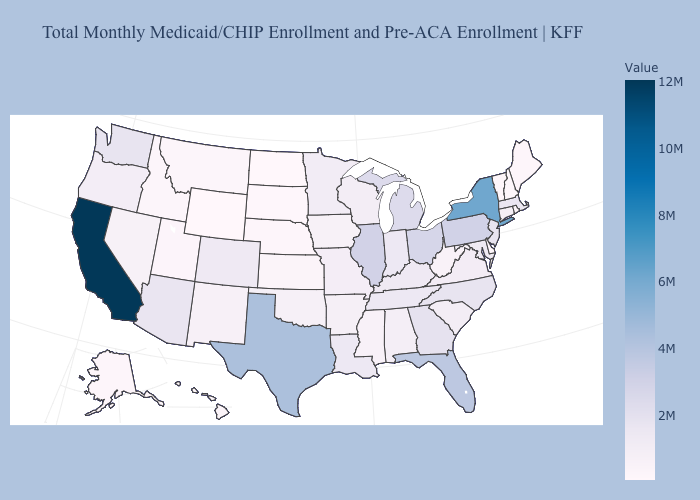Among the states that border New Mexico , does Utah have the lowest value?
Give a very brief answer. Yes. Among the states that border South Dakota , does Iowa have the highest value?
Keep it brief. No. Which states have the highest value in the USA?
Keep it brief. California. Which states have the highest value in the USA?
Give a very brief answer. California. Among the states that border New York , does Connecticut have the lowest value?
Give a very brief answer. No. Does Wyoming have the lowest value in the West?
Concise answer only. Yes. 